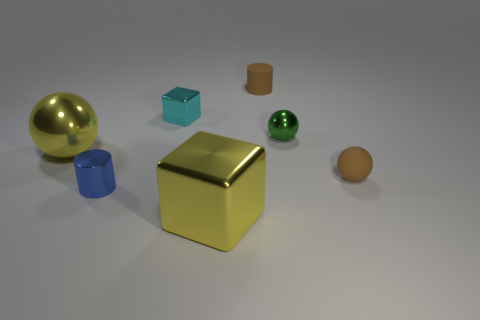Do the yellow thing in front of the tiny rubber ball and the brown object that is on the right side of the matte cylinder have the same material?
Keep it short and to the point. No. How many objects are green metallic balls or objects in front of the large yellow metallic ball?
Your answer should be compact. 4. There is a thing that is the same color as the rubber cylinder; what shape is it?
Offer a very short reply. Sphere. What is the yellow sphere made of?
Offer a very short reply. Metal. Is the material of the big yellow ball the same as the tiny cube?
Provide a short and direct response. Yes. How many metallic objects are blue things or tiny green spheres?
Your answer should be very brief. 2. There is a big yellow shiny object that is behind the large metal cube; what is its shape?
Your answer should be compact. Sphere. There is a blue thing that is the same material as the big yellow sphere; what size is it?
Your answer should be compact. Small. What shape is the metal thing that is both to the left of the tiny cyan object and in front of the brown ball?
Give a very brief answer. Cylinder. There is a ball to the left of the green ball; is it the same color as the big shiny cube?
Your response must be concise. Yes. 